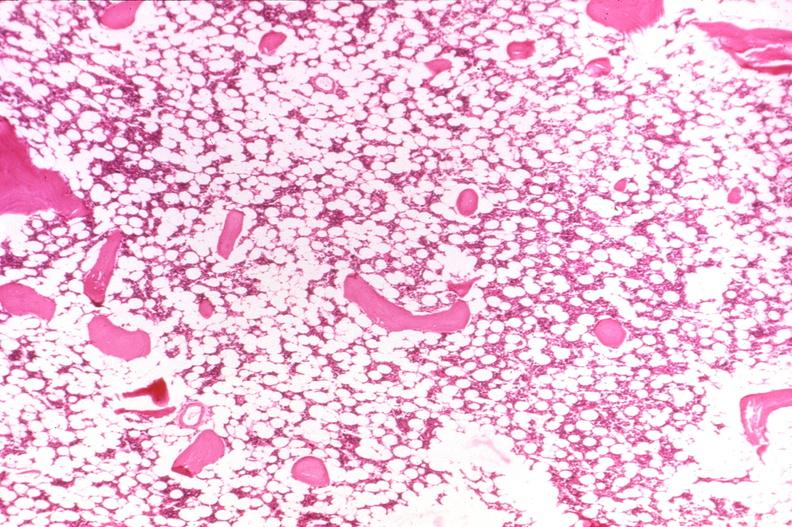s joints present?
Answer the question using a single word or phrase. Yes 